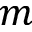<formula> <loc_0><loc_0><loc_500><loc_500>m</formula> 